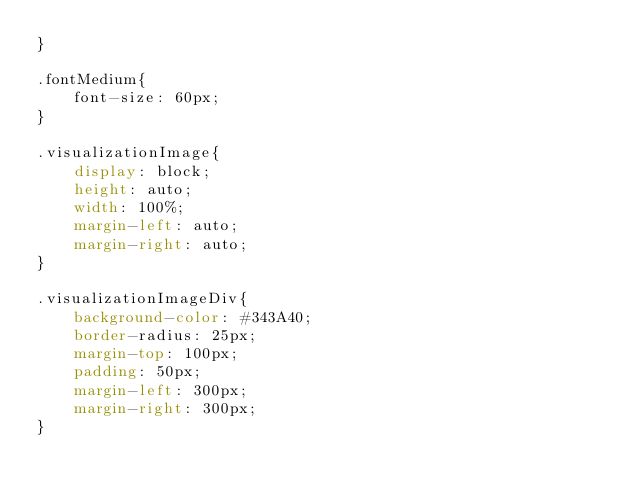<code> <loc_0><loc_0><loc_500><loc_500><_CSS_>}

.fontMedium{
    font-size: 60px;
}

.visualizationImage{
    display: block;
    height: auto;
    width: 100%;
    margin-left: auto;
    margin-right: auto;
}

.visualizationImageDiv{
    background-color: #343A40;
    border-radius: 25px;
    margin-top: 100px;
    padding: 50px;
    margin-left: 300px;
    margin-right: 300px;
}</code> 